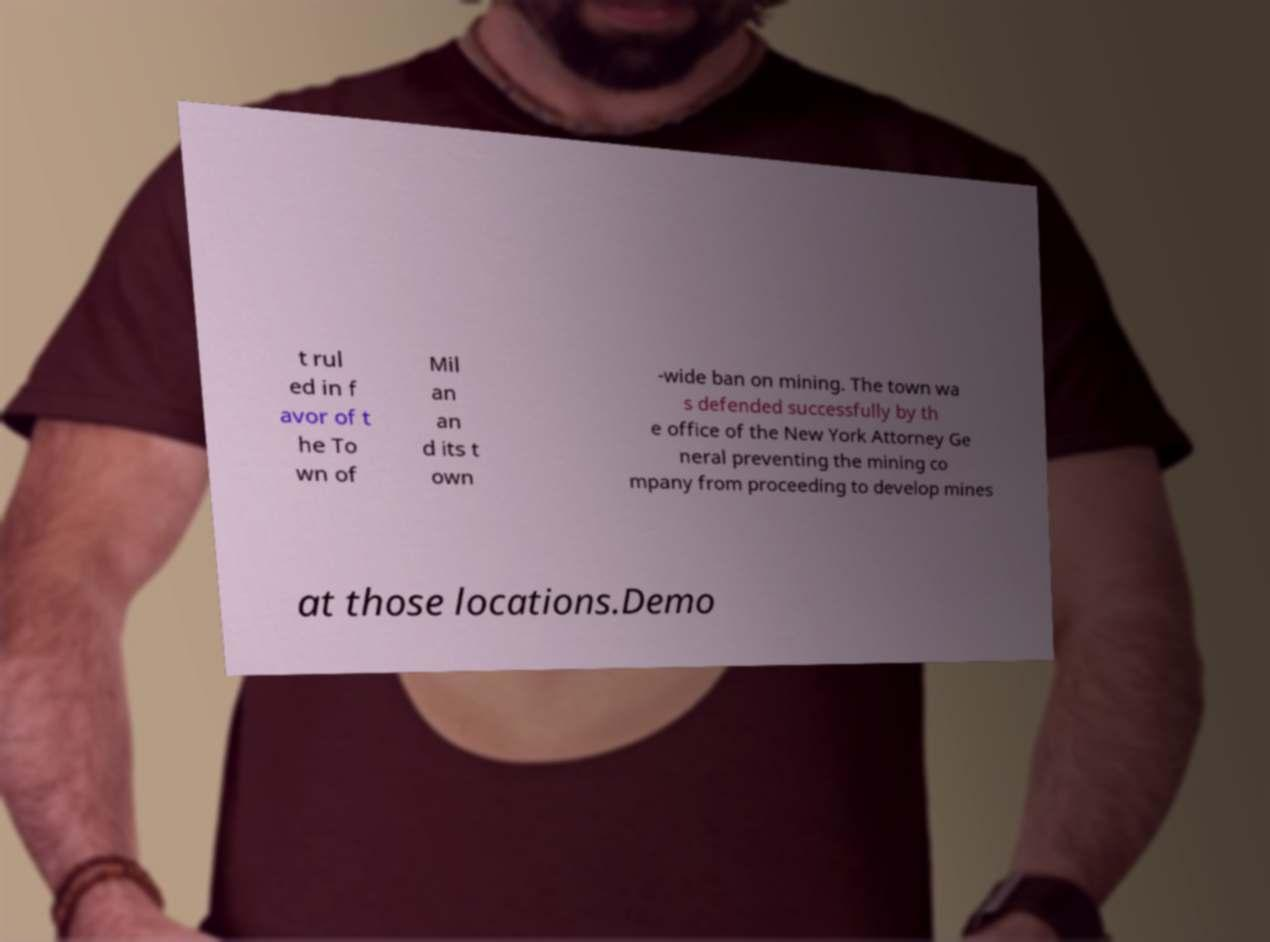Please read and relay the text visible in this image. What does it say? t rul ed in f avor of t he To wn of Mil an an d its t own -wide ban on mining. The town wa s defended successfully by th e office of the New York Attorney Ge neral preventing the mining co mpany from proceeding to develop mines at those locations.Demo 